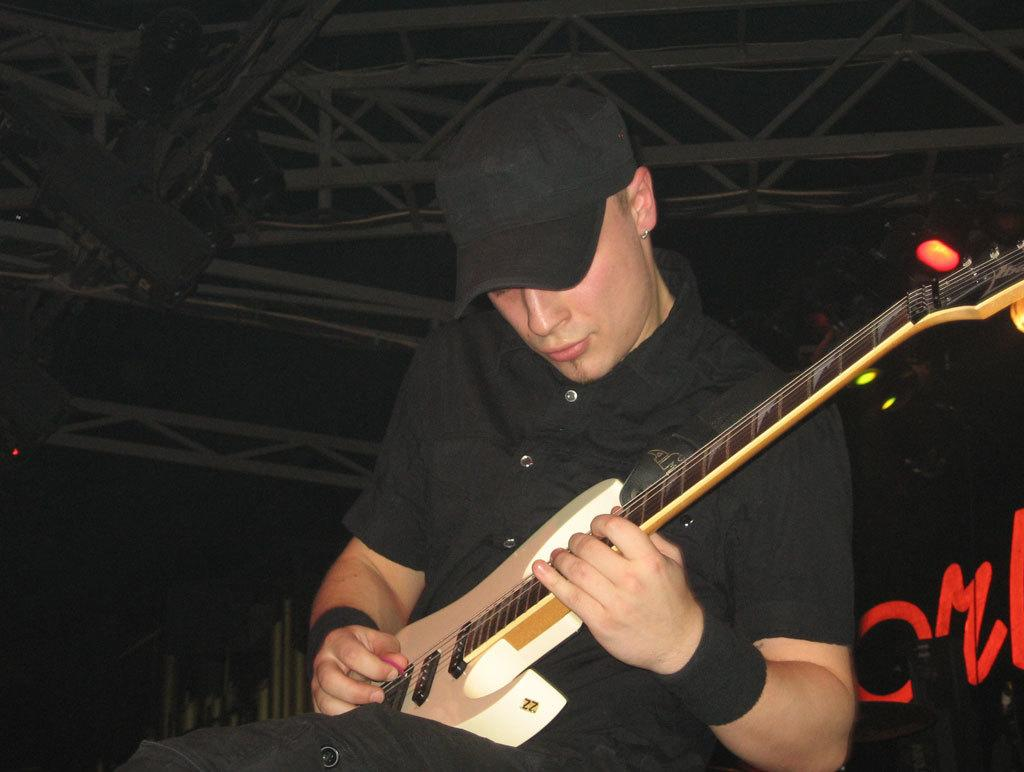What is the man in the image doing? The man is playing a guitar in the image. What accessory is the man wearing on his head? The man is wearing a cap in the image. What type of skirt is the man wearing in the image? The man is not wearing a skirt in the image; he is wearing a cap. 